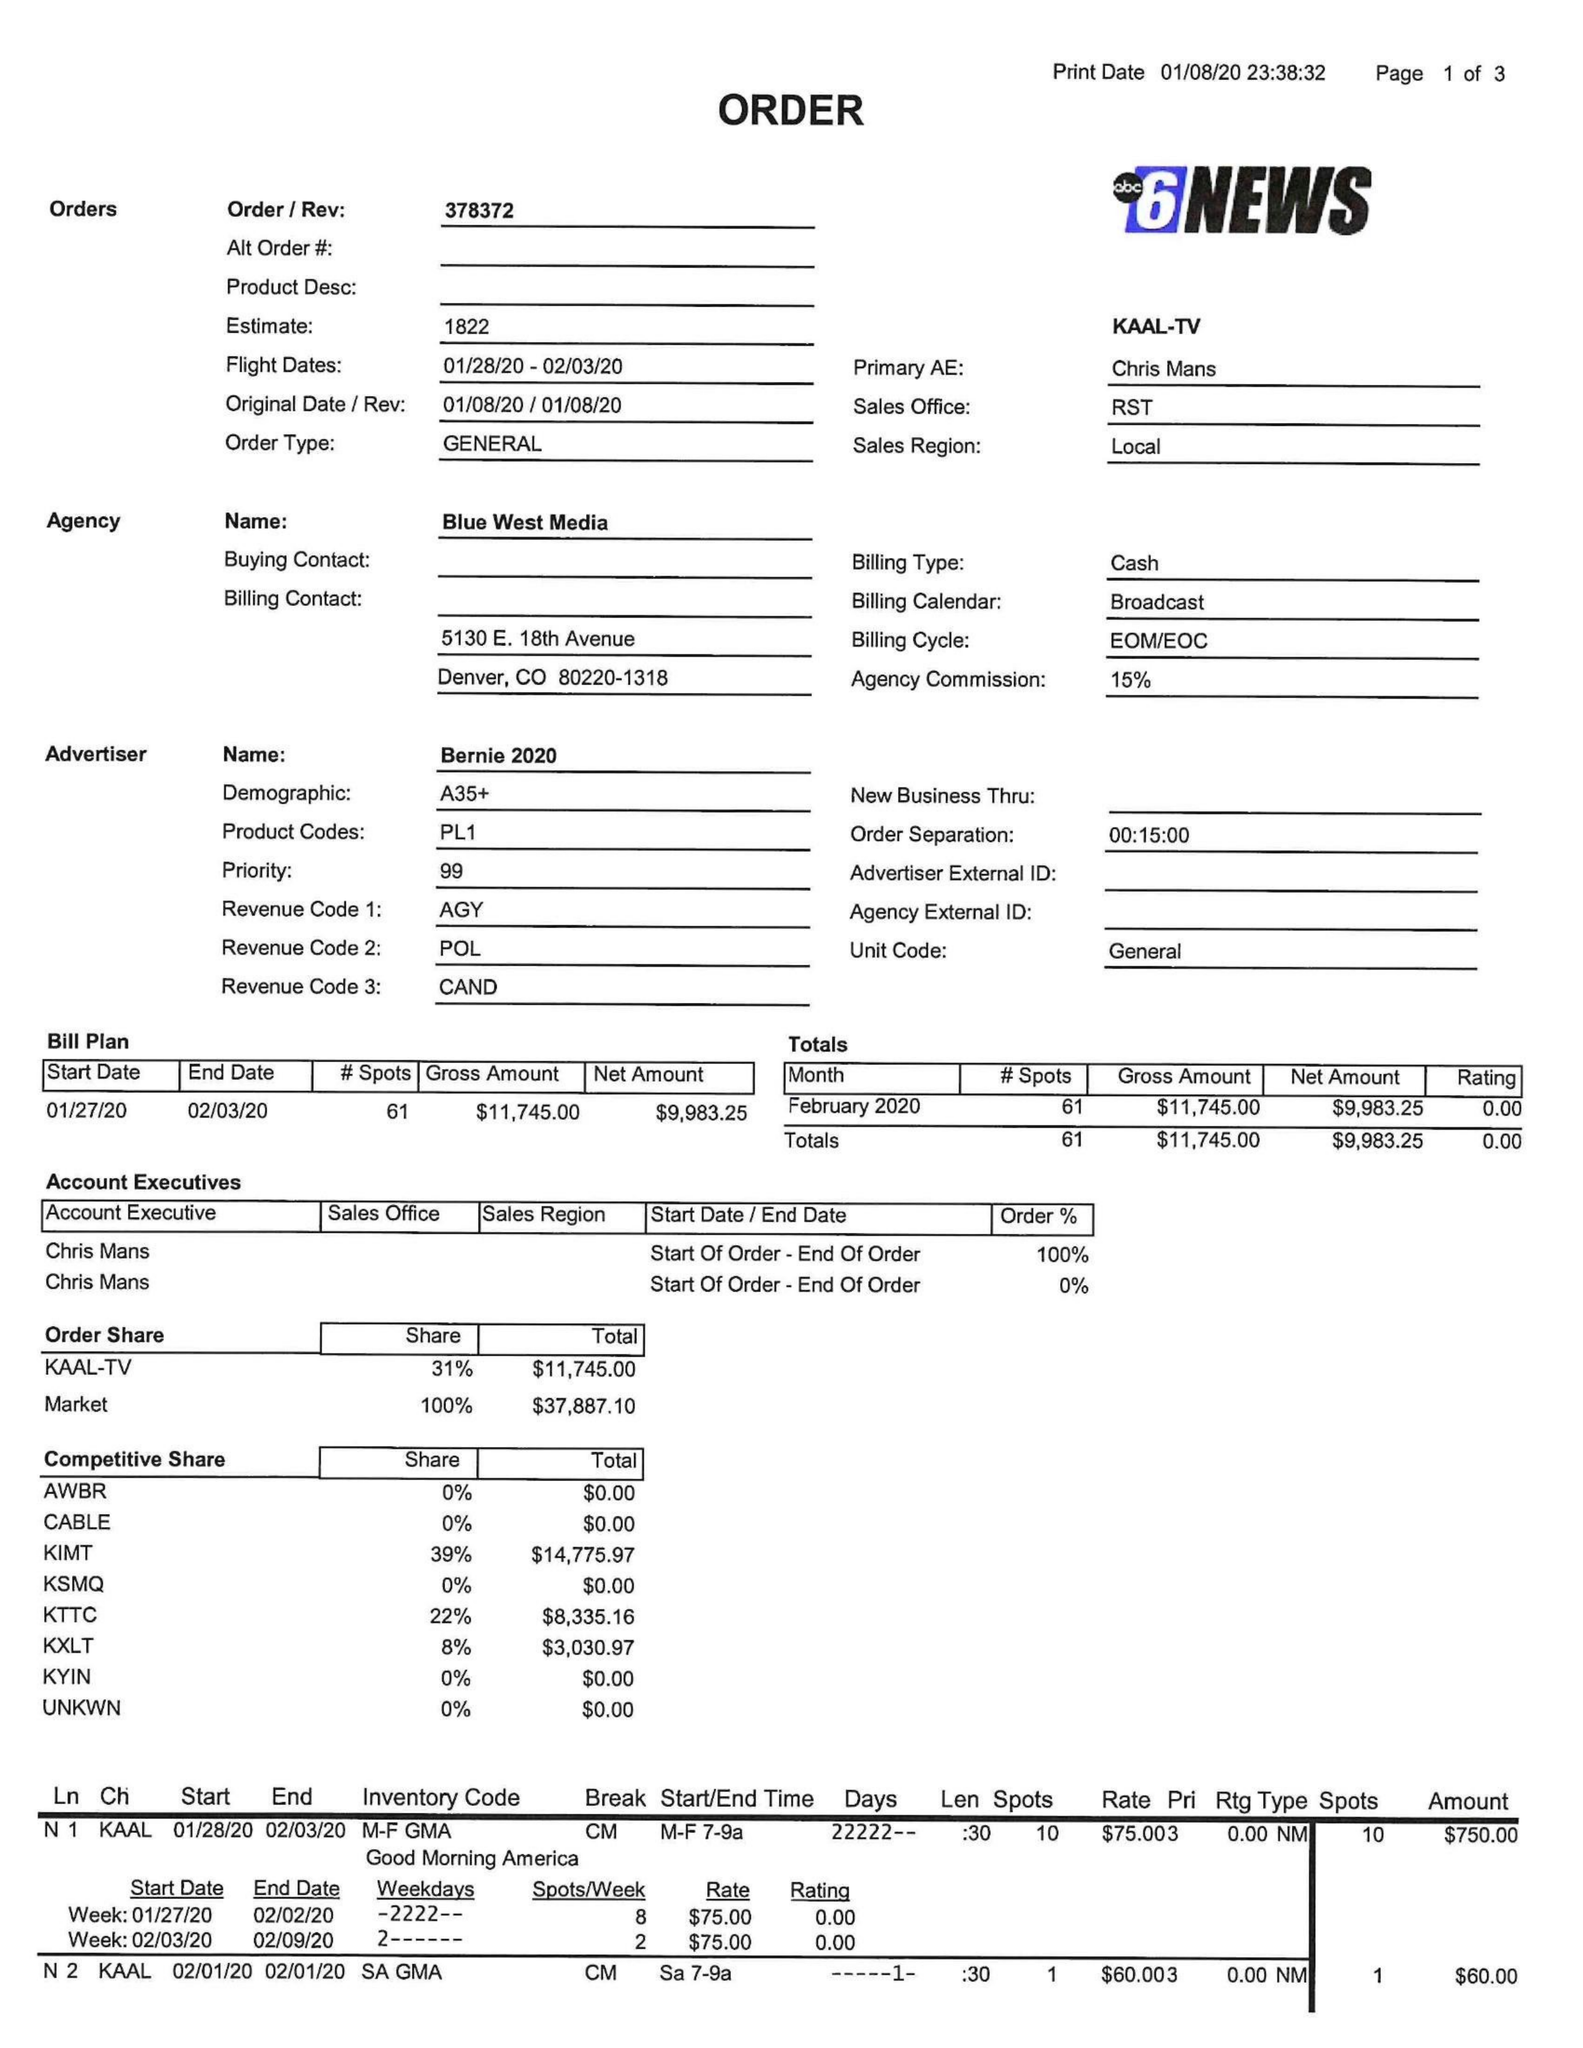What is the value for the advertiser?
Answer the question using a single word or phrase. BERNIE 2020 